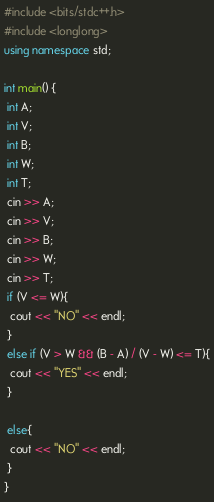<code> <loc_0><loc_0><loc_500><loc_500><_C++_>#include <bits/stdc++.h>
#include <longlong>
using namespace std;
 
int main() {
 int A;
 int V;
 int B;
 int W;
 int T;
 cin >> A;
 cin >> V;
 cin >> B;
 cin >> W;
 cin >> T;
 if (V <= W){
  cout << "NO" << endl;
 }
 else if (V > W && (B - A) / (V - W) <= T){
  cout << "YES" << endl;
 }
  
 else{
  cout << "NO" << endl;
 }
}</code> 